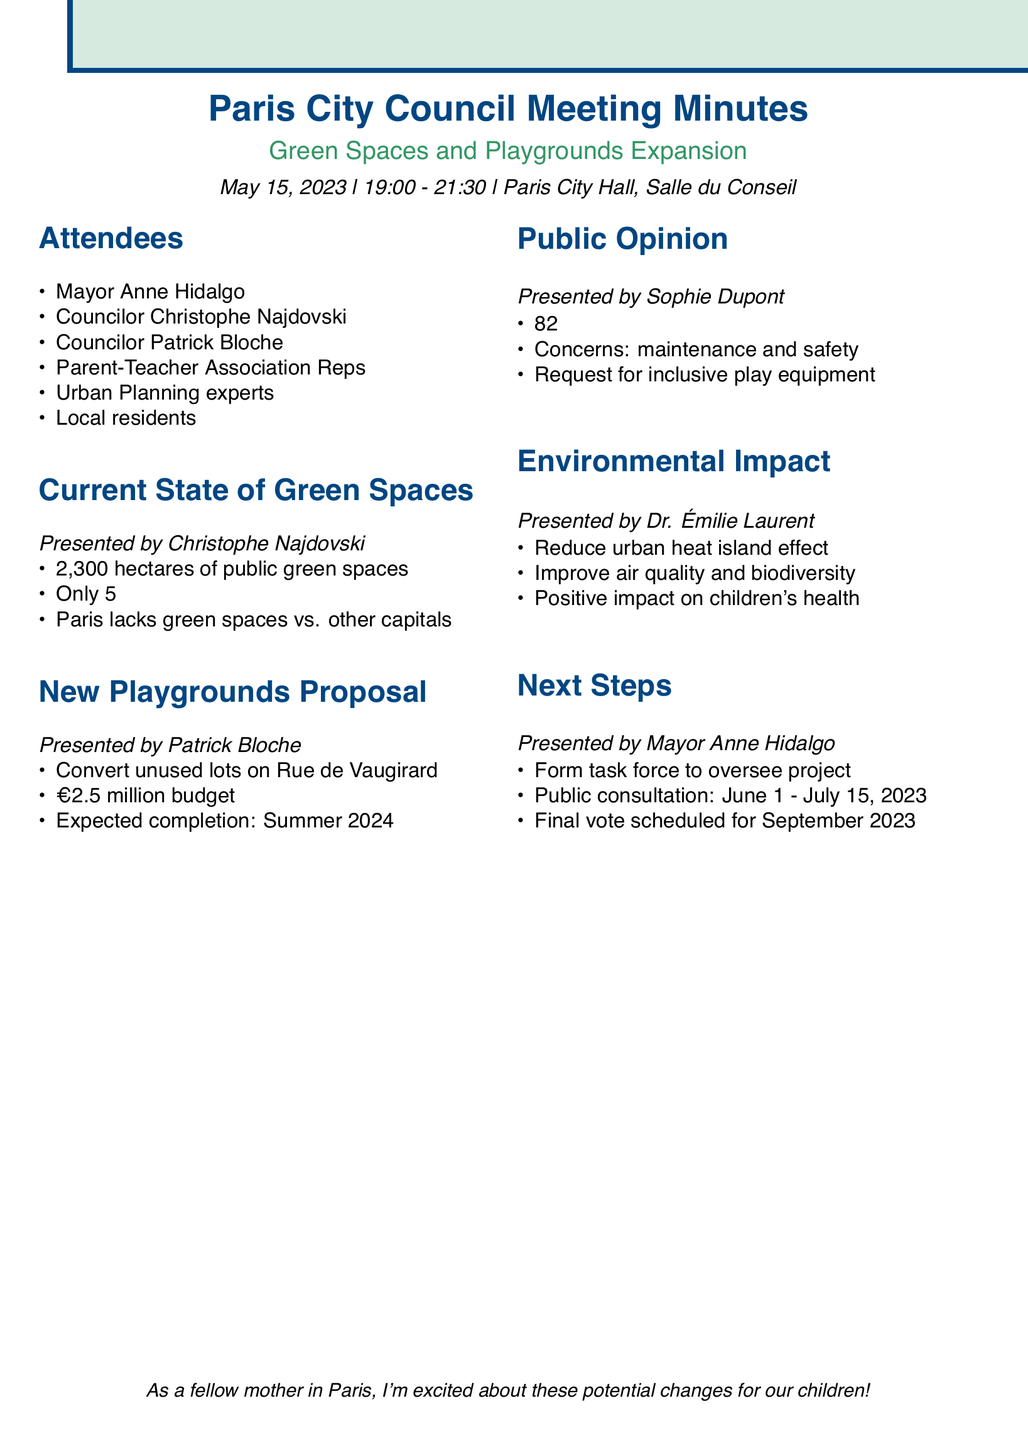What is the date of the meeting? The date of the meeting is specified in the document as May 15, 2023.
Answer: May 15, 2023 Who presented the proposal for new playgrounds? The document states that the proposal for new playgrounds was presented by Patrick Bloche.
Answer: Patrick Bloche How many hectares of public green spaces does Paris currently have? According to the meeting minutes, Paris currently has 2,300 hectares of public green spaces.
Answer: 2,300 hectares What percentage of the city area is dedicated to parks and gardens? The document indicates that only 5% of the city area is dedicated to parks and gardens.
Answer: 5% What is the proposed budget for the playground project? As mentioned in the document, the proposed budget for the playground project is €2.5 million.
Answer: €2.5 million How many local parents support more green spaces according to the survey? The survey results reveal that 82% of local parents support more green spaces.
Answer: 82% What are the next steps mentioned in the meeting? The next steps include forming a task force and a public consultation period.
Answer: Formation of a task force and public consultation When is the expected completion date for the playgrounds? The expected completion date for the playgrounds is scheduled for Summer 2024.
Answer: Summer 2024 What is one concern raised by local parents regarding new playgrounds? One concern raised by local parents is about the maintenance and safety of new playgrounds.
Answer: Maintenance and safety 